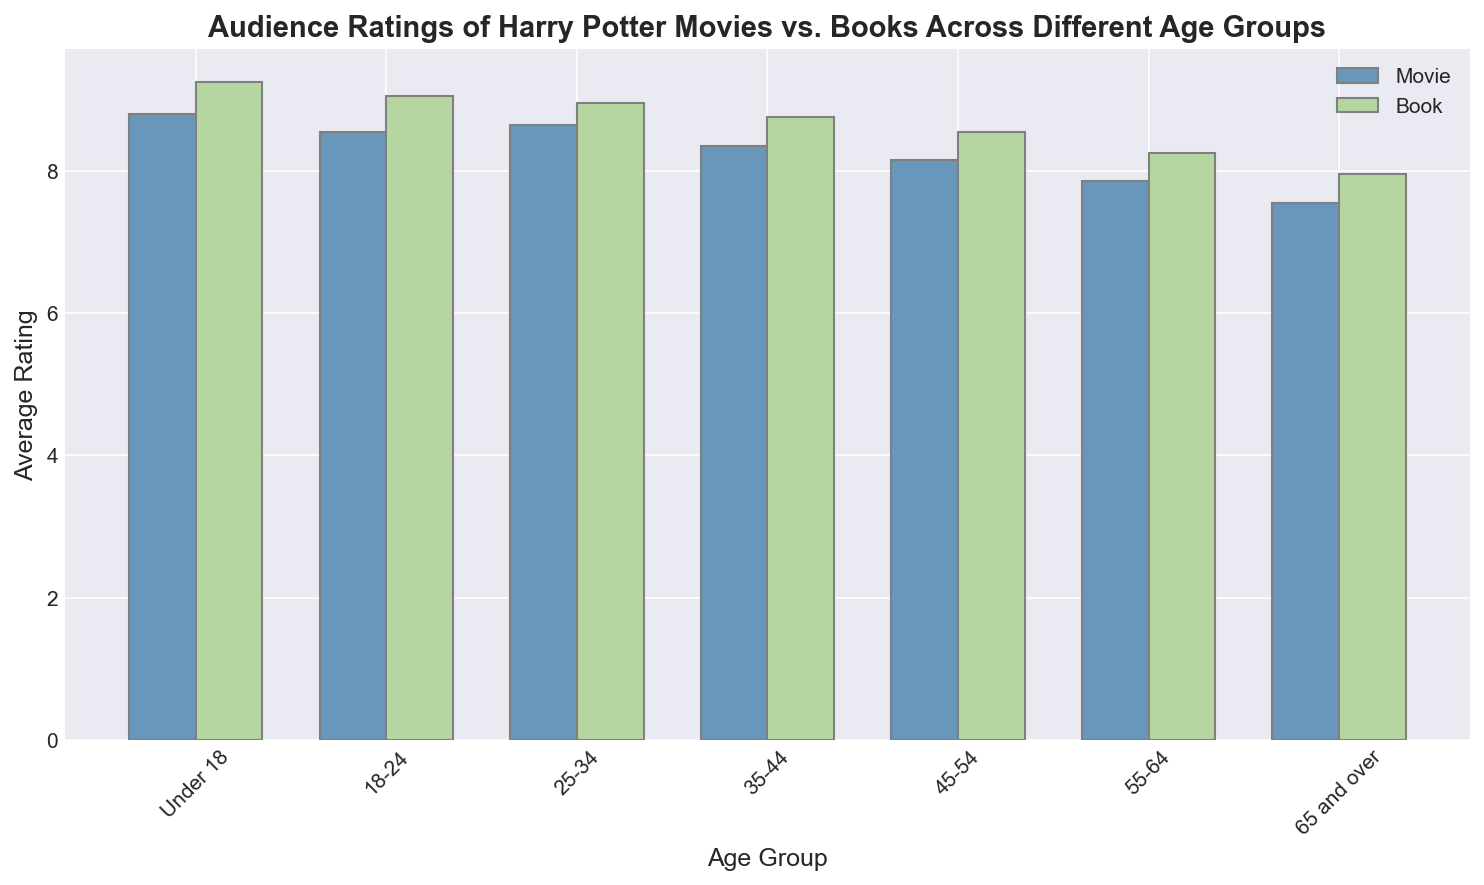What is the average rating of the Harry Potter books given by the age group '25-34'? Look at the bar height for the '25-34' age group under the book rating category. It’s slightly above 8.9.
Answer: 8.9 Among all age groups, who has given the highest rating to the movies and what is that rating? Look for the tallest bar in the 'Movie' category. The 'Under 18' group has given the highest rating to the movies, which is around 8.9.
Answer: Under 18, 8.9 Which age group has the smallest difference between movie and book ratings? Calculate the difference between movie and book ratings for each age group, and identify the smallest one. For '18-24', movie rating is 8.5 and book rating is 9.0, difference is 0.5, which is the smallest among all groups.
Answer: 18-24 What age group gave a movie rating lower than the book rating by at least 1 point? Compare movie and book ratings for each age group and find the group with a difference of at least 1. The '65 and over' group’s movie rating is 7.5 and book rating is 8.0, and difference is 0.5, which does not meet the criteria. No group fits the condition.
Answer: None Which age group shows the largest discrepancy between movie and book ratings? Identify the age group with the highest difference between movie and book ratings. The 'Under 18' group shows a book rating of 9.3 and movie rating of 8.9, difference of 0.4, but the largest discrepancy is in the '18-24' group, with a 0.5 difference.
Answer: 18-24 Compare the book ratings for the '35-44' and '45-54' groups. Which one is higher, and by how much? The '35-44' group has a book rating of approximately 8.8, and '45-54' has around 8.6. The difference is about 0.2.
Answer: 35-44, 0.2 Is there an age group where the movie rating is equal to the book rating? Compare movie and book ratings for each age group. None of the age groups has equal ratings for movie and book.
Answer: No Which age group gave the lowest rating for Harry Potter movies? Identify the shortest bar in the 'Movie' category. The '65 and over' group gave the lowest rating, which is around 7.5.
Answer: 65 and over, 7.5 What is the general trend in ratings as the age group increases? Observe the pattern of heights of bars from left to right for both movie and book categories. Ratings generally decrease as the age group increases for both movie and book.
Answer: Decreasing 